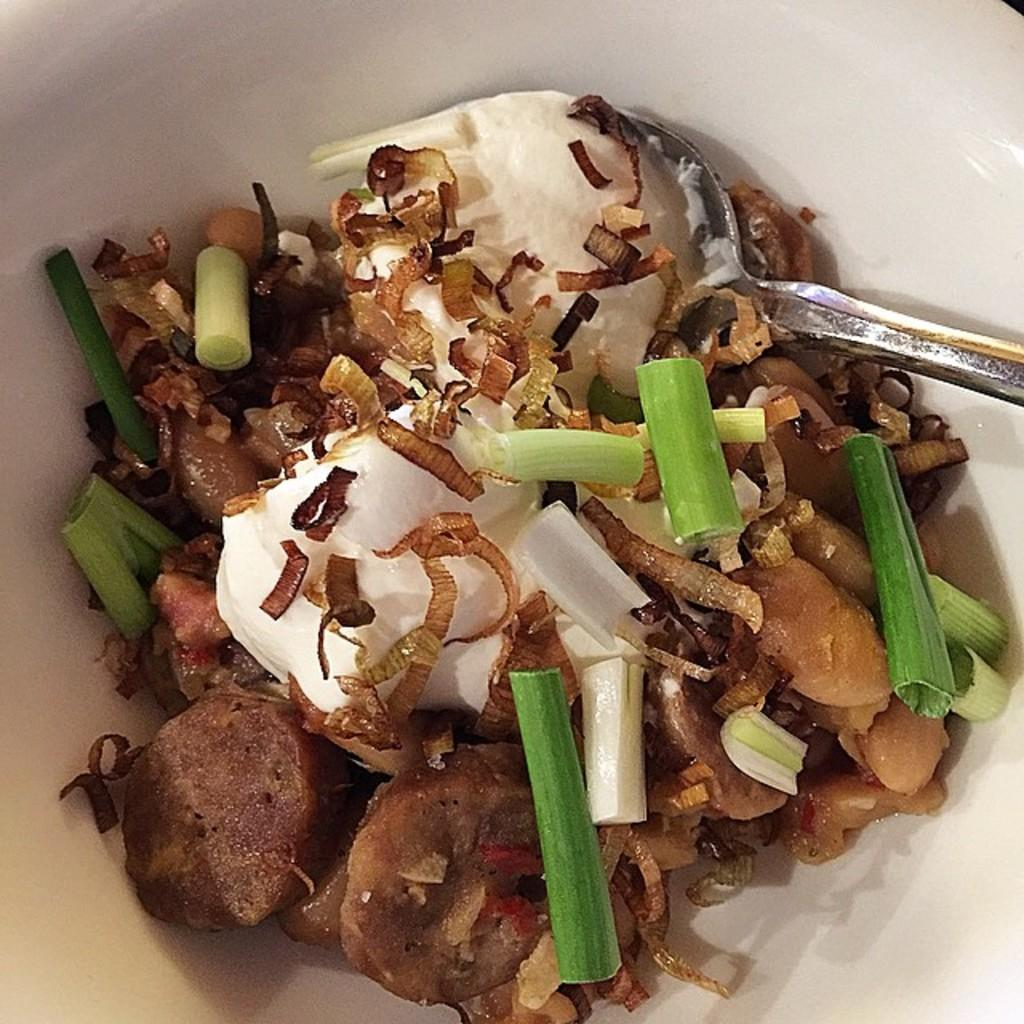What is on the plate in the image? There is food on a white color plate in the image. Can you describe the colors of the food? The food has green, white, and brown colors. What utensil is present in the food? There is a spoon in the food. How many houses can be seen in the image? There are no houses present in the image; it features a plate of food with a spoon. What sense is being stimulated by the food in the image? The image does not provide information about which sense is being stimulated by the food. 